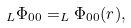<formula> <loc_0><loc_0><loc_500><loc_500>_ { L } \Phi _ { 0 0 } = _ { L } \Phi _ { 0 0 } ( r ) ,</formula> 